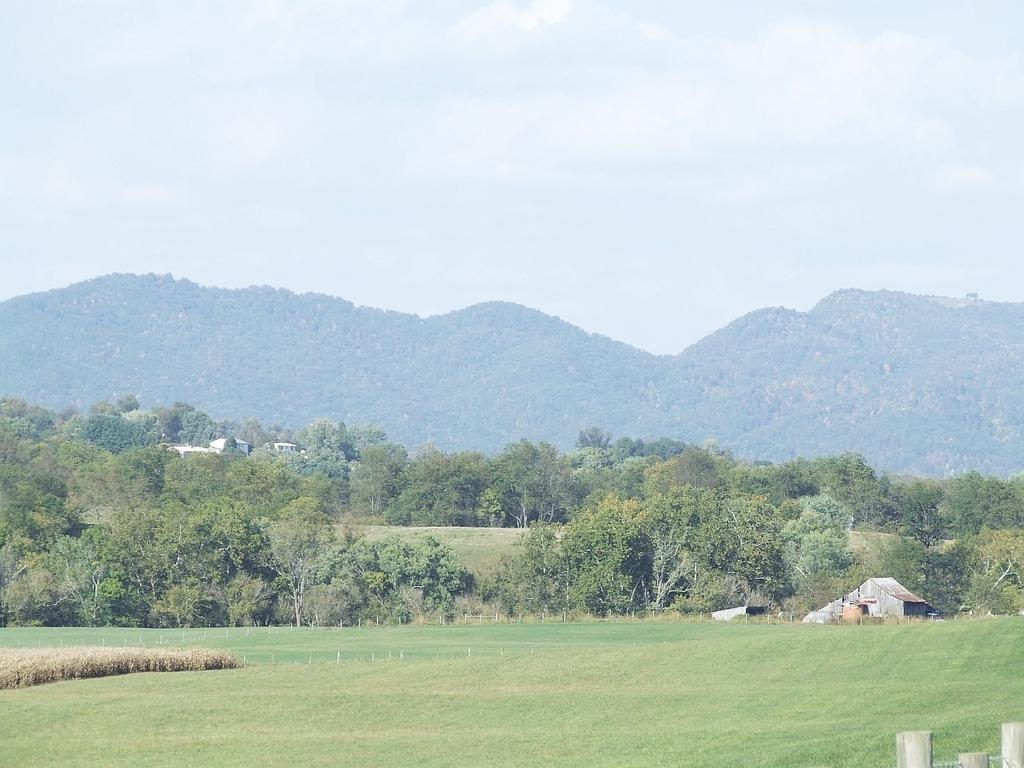What is covering the ground in the image? The ground in the image is covered in greenery. What can be seen in the background of the image? There are trees and mountains in the background of the image. What is the condition of the sky in the image? The sky is cloudy in the image. Can you tell me what type of doctor is standing near the trees in the image? There is no doctor present in the image; it features greenery, trees, mountains, and a cloudy sky. What color are the eyes of the person standing near the mountains in the image? There is no person present in the image, only the ground, trees, mountains, and sky. 